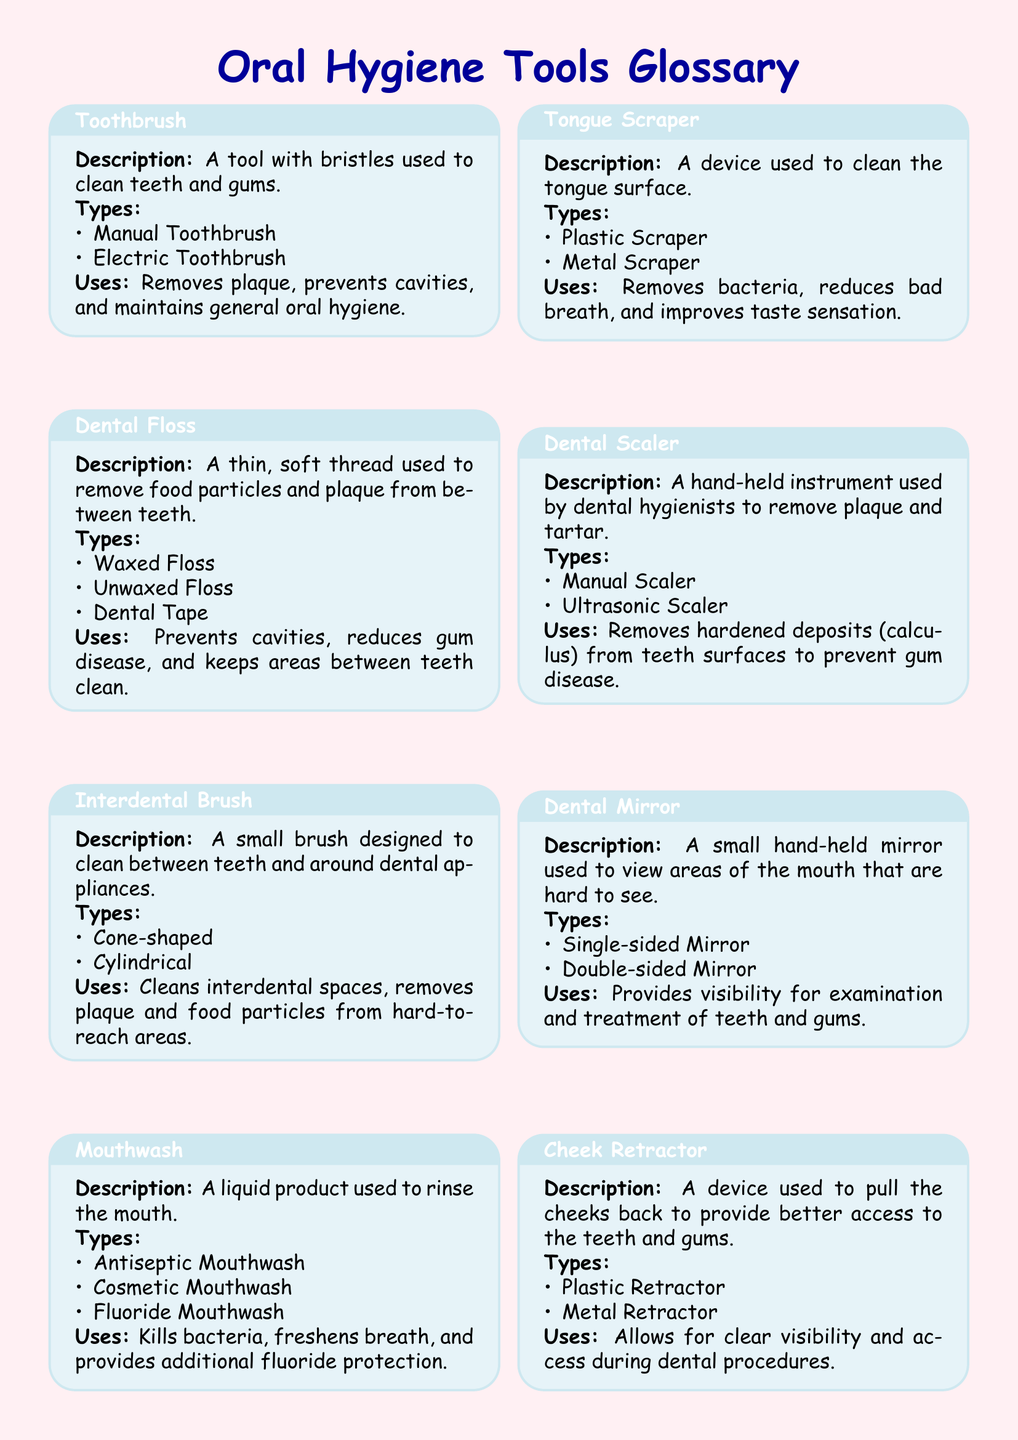What is a toothbrush? A toothbrush is a tool with bristles used to clean teeth and gums.
Answer: A tool with bristles used to clean teeth and gums How many types of dental floss are there? The document lists three types of dental floss: Waxed Floss, Unwaxed Floss, and Dental Tape.
Answer: Three types What is the use of a tongue scraper? The tongue scraper is used to remove bacteria, reduce bad breath, and improve taste sensation.
Answer: Removes bacteria What type of mouthwash is mentioned for additional fluoride protection? The document specifies Fluoride Mouthwash as providing additional fluoride protection.
Answer: Fluoride Mouthwash What is the main purpose of a dental scaler? The dental scaler is used to remove hardened deposits (calculus) from teeth surfaces.
Answer: Remove hardened deposits Which tool provides visibility for examination and treatment? The dental mirror provides visibility for examining and treating teeth and gums.
Answer: Dental Mirror What is the function of a saliva ejector? A saliva ejector is used to keep the mouth clean and dry during dental procedures.
Answer: Keeps the mouth clean and dry What do cheek retractors help improve during procedures? Cheek retractors help improve visibility and access during dental procedures.
Answer: Visibility and access 